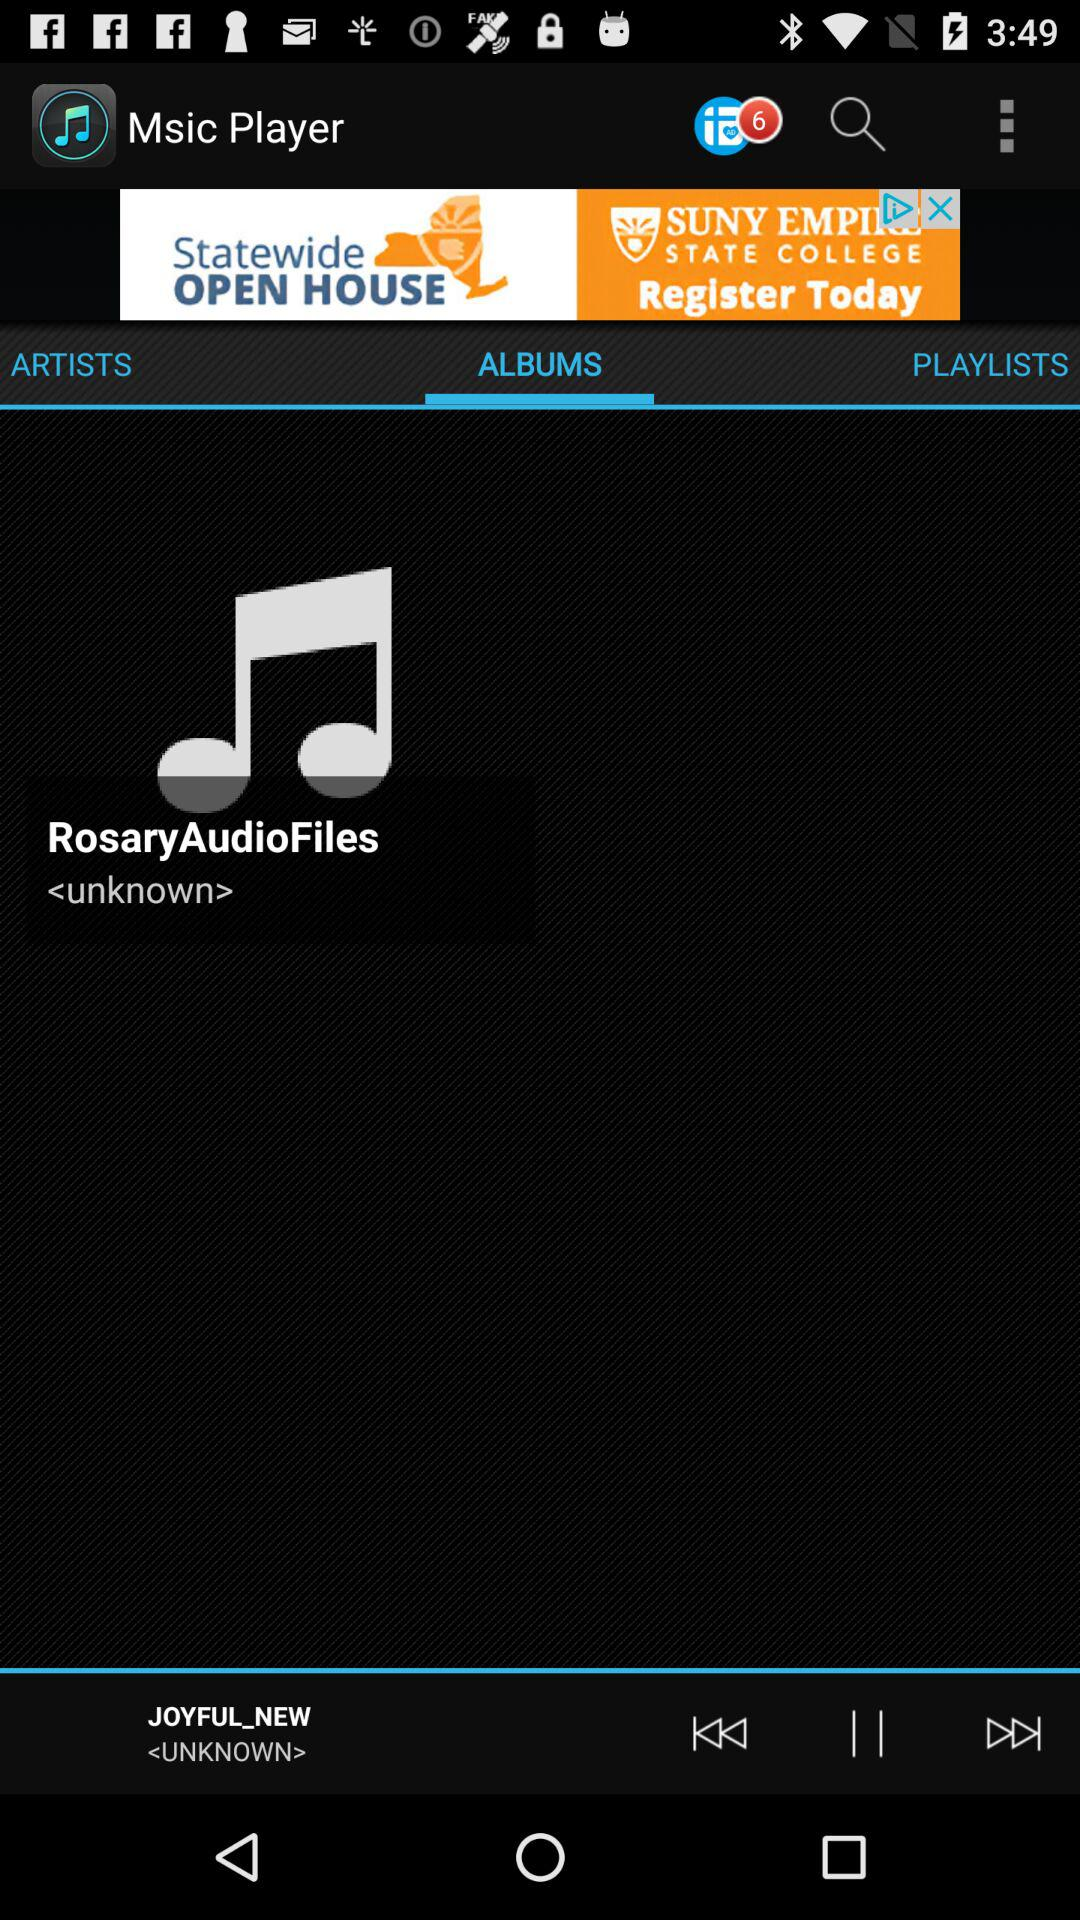What is the name of the song shown on the screen? The name of the song shown on the screen is "JOYFUL_NEW". 